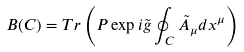Convert formula to latex. <formula><loc_0><loc_0><loc_500><loc_500>B ( C ) = T r \left ( P \exp i \tilde { g } \oint _ { C } \tilde { A } _ { \mu } d x ^ { \mu } \right )</formula> 